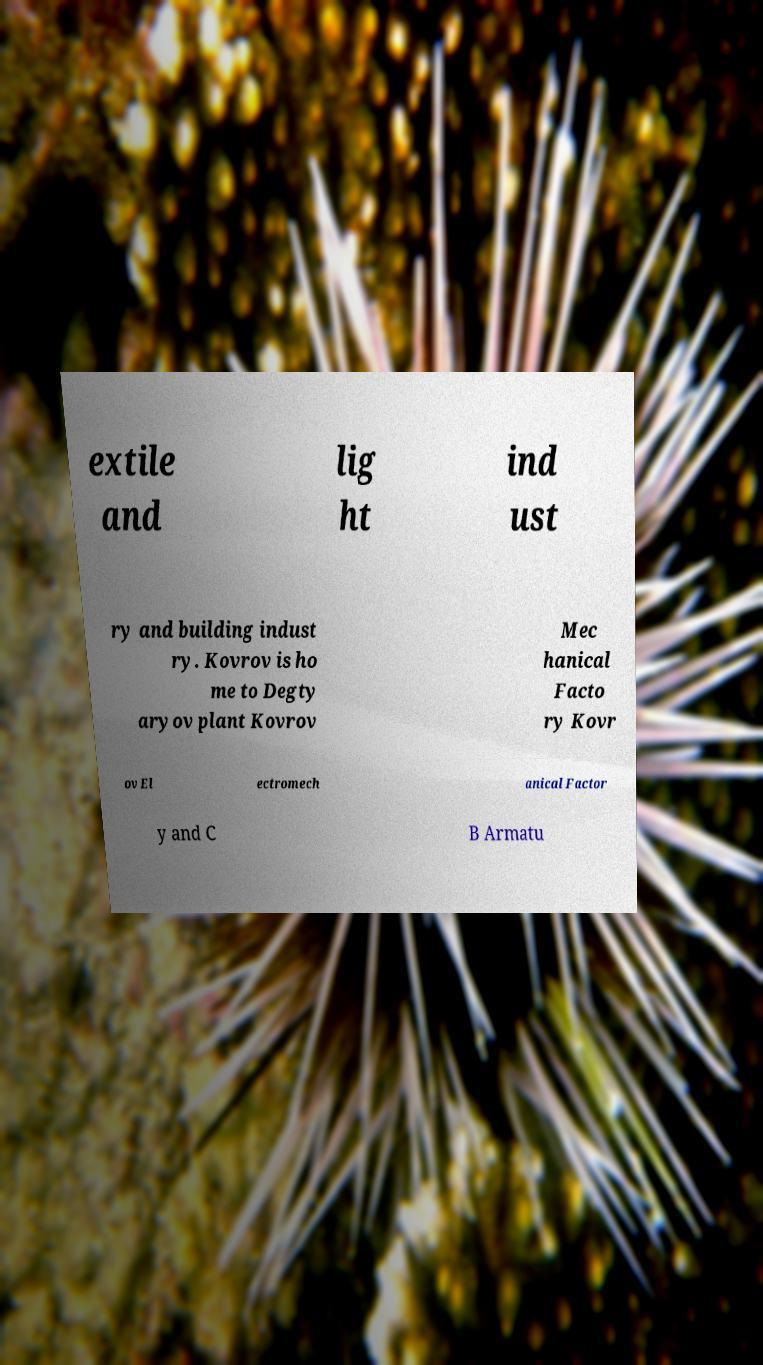Can you accurately transcribe the text from the provided image for me? extile and lig ht ind ust ry and building indust ry. Kovrov is ho me to Degty aryov plant Kovrov Mec hanical Facto ry Kovr ov El ectromech anical Factor y and C B Armatu 